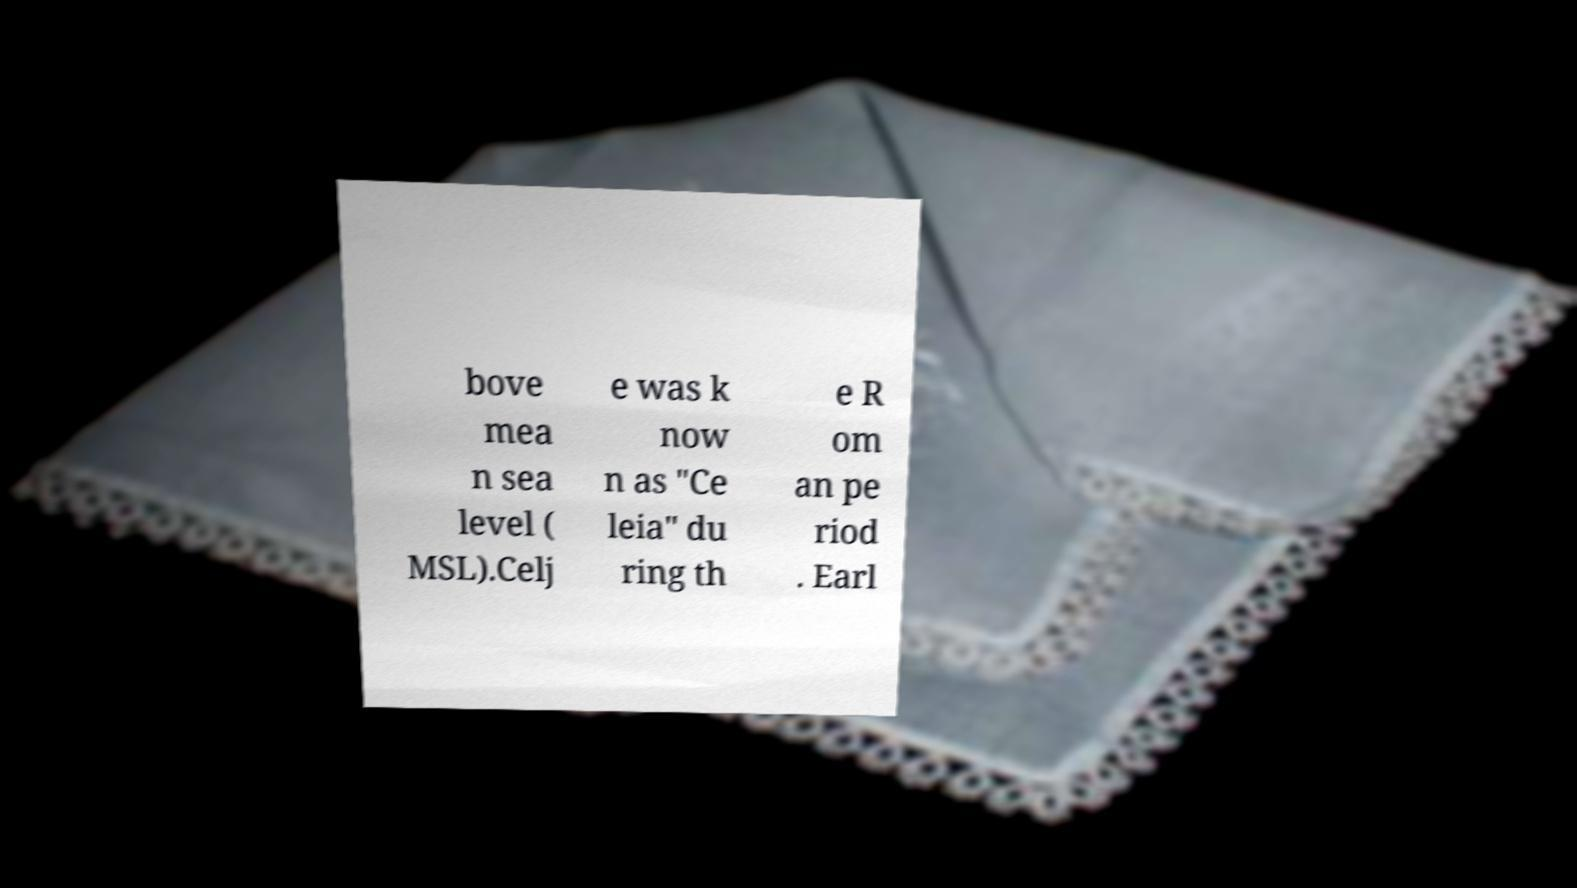I need the written content from this picture converted into text. Can you do that? bove mea n sea level ( MSL).Celj e was k now n as "Ce leia" du ring th e R om an pe riod . Earl 